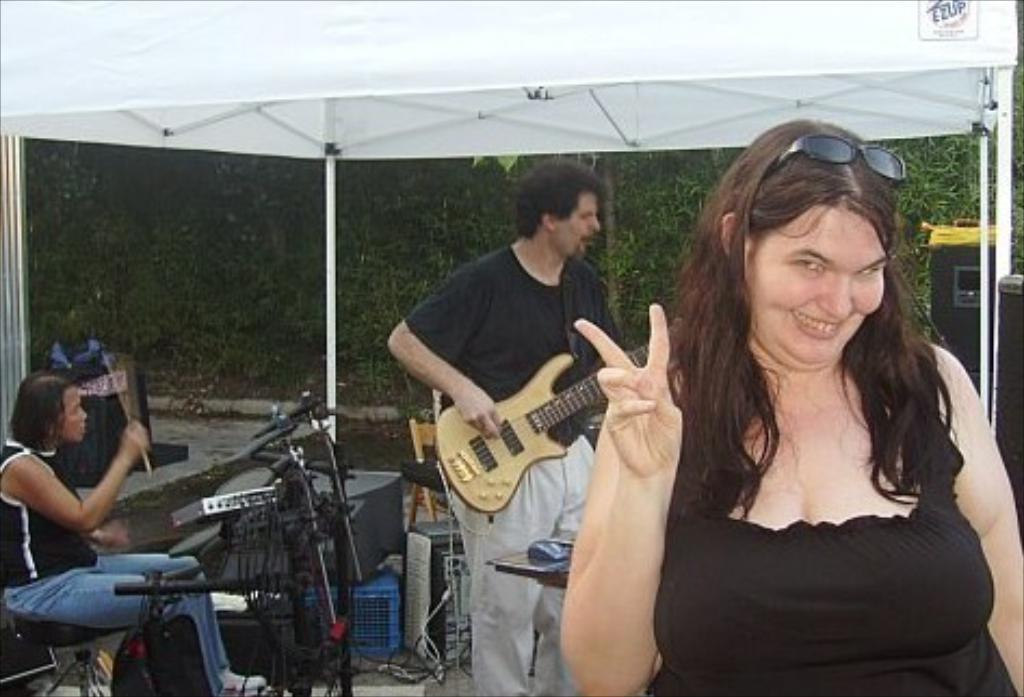How many people are in the image? There are three persons in the image. Can you describe the woman in the image? The woman is smiling. What musical instruments are being played in the image? A guitar and drums are being played in the image. What can be seen in the background of the image? Trees, a tent, speakers, and clothes are visible in the background of the image. What type of flame can be seen coming from the bikes in the image? There are no bikes present in the image, so there is no flame coming from them. 